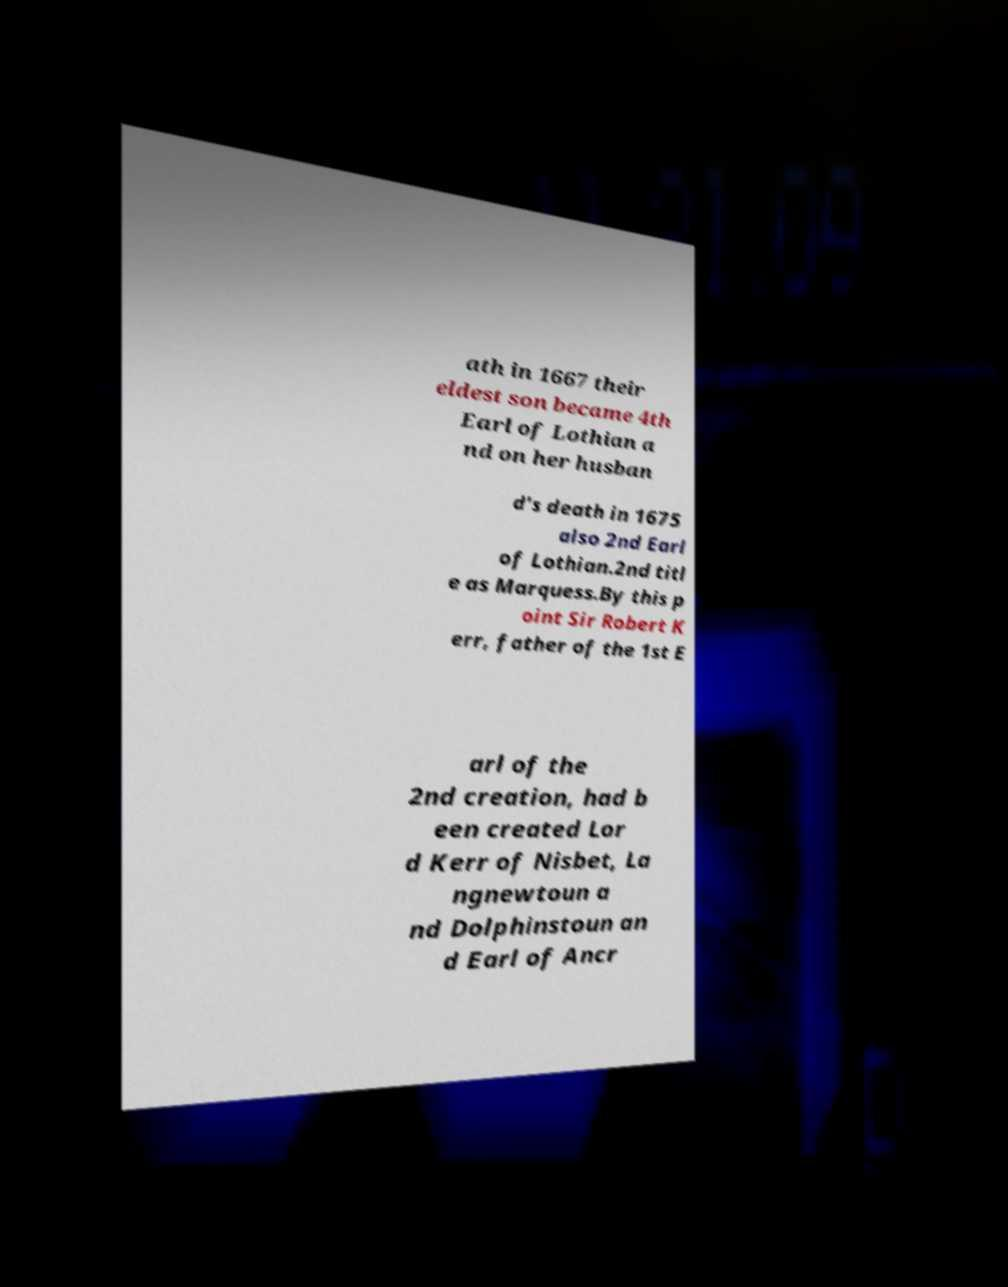What messages or text are displayed in this image? I need them in a readable, typed format. ath in 1667 their eldest son became 4th Earl of Lothian a nd on her husban d's death in 1675 also 2nd Earl of Lothian.2nd titl e as Marquess.By this p oint Sir Robert K err, father of the 1st E arl of the 2nd creation, had b een created Lor d Kerr of Nisbet, La ngnewtoun a nd Dolphinstoun an d Earl of Ancr 